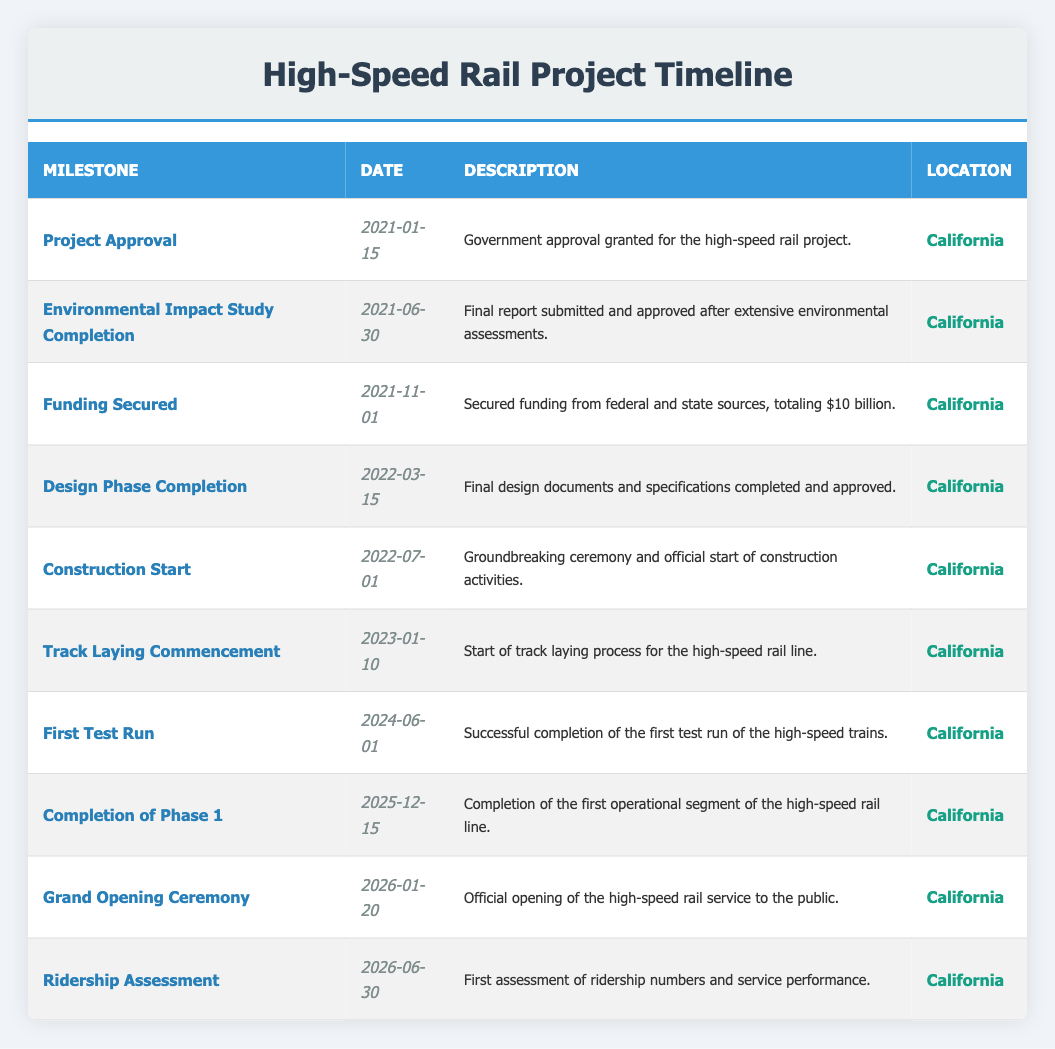What was the date of the Project Approval milestone? The Project Approval milestone is listed in the table with its corresponding date, which is clearly specified as January 15, 2021.
Answer: January 15, 2021 How many days are there between the Funding Secured and Design Phase Completion milestones? The Funding Secured milestone occurs on November 1, 2021, and the Design Phase Completion milestone is on March 15, 2022. Calculating the difference: from November 1, 2021, to March 15, 2022, is 4 months and 14 days, which is 134 days in total.
Answer: 134 days Was the first test run scheduled before the environmental impact study was completed? The first test run is scheduled for June 1, 2024, and the environmental impact study was completed on June 30, 2021. Since June 1, 2024 is after June 30, 2021, this statement is false.
Answer: No What is the total number of milestones listed in the table? The table details 10 unique milestones ranging from Project Approval to Ridership Assessment. Therefore, the total number of milestones is 10.
Answer: 10 What is the duration from the start of construction to the grand opening ceremony? The Construction Start is on July 1, 2022, and the Grand Opening Ceremony is on January 20, 2026. Calculating the duration: from July 1, 2022, to January 20, 2026, is 3 years, 6 months, and 19 days, totaling approximately 1,316 days.
Answer: Approximately 1,316 days How many phases must be completed before the first test run? The table indicates that Project Approval, Funding Secured, Design Phase Completion, and Construction Start are all required before the first test run can occur. This involves 4 milestones.
Answer: 4 Was the Grand Opening Ceremony held on a weekend? The Grand Opening Ceremony is scheduled for January 20, 2026, which is a Wednesday. Therefore, this event was not held on a weekend.
Answer: No Which milestone occurs immediately before the Completion of Phase 1? The milestone that occurs immediately before the Completion of Phase 1, which is on December 15, 2025, is the First Test Run scheduled for June 1, 2024. Therefore, it is the milestone preceding it.
Answer: First Test Run 